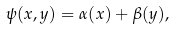Convert formula to latex. <formula><loc_0><loc_0><loc_500><loc_500>\psi ( x , y ) = \alpha ( x ) + \beta ( y ) ,</formula> 